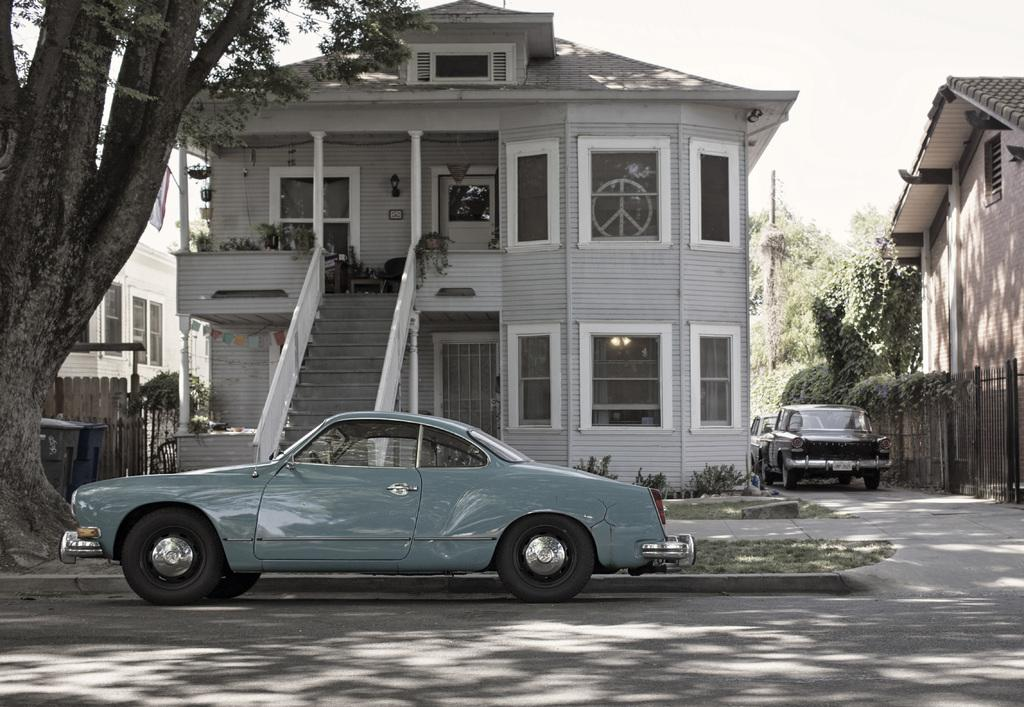What type of vehicles can be seen in the image? There are cars in the image. What structures are present in the image? There are buildings in the image. What type of vegetation is visible in the image? There are trees in the image. What is the condition of the sky in the image? The sky is visible in the image, and it appears to be cloudy. What type of cushion is being used for the activity in the image? There is no cushion or activity present in the image; it features cars, buildings, trees, and a cloudy sky. 